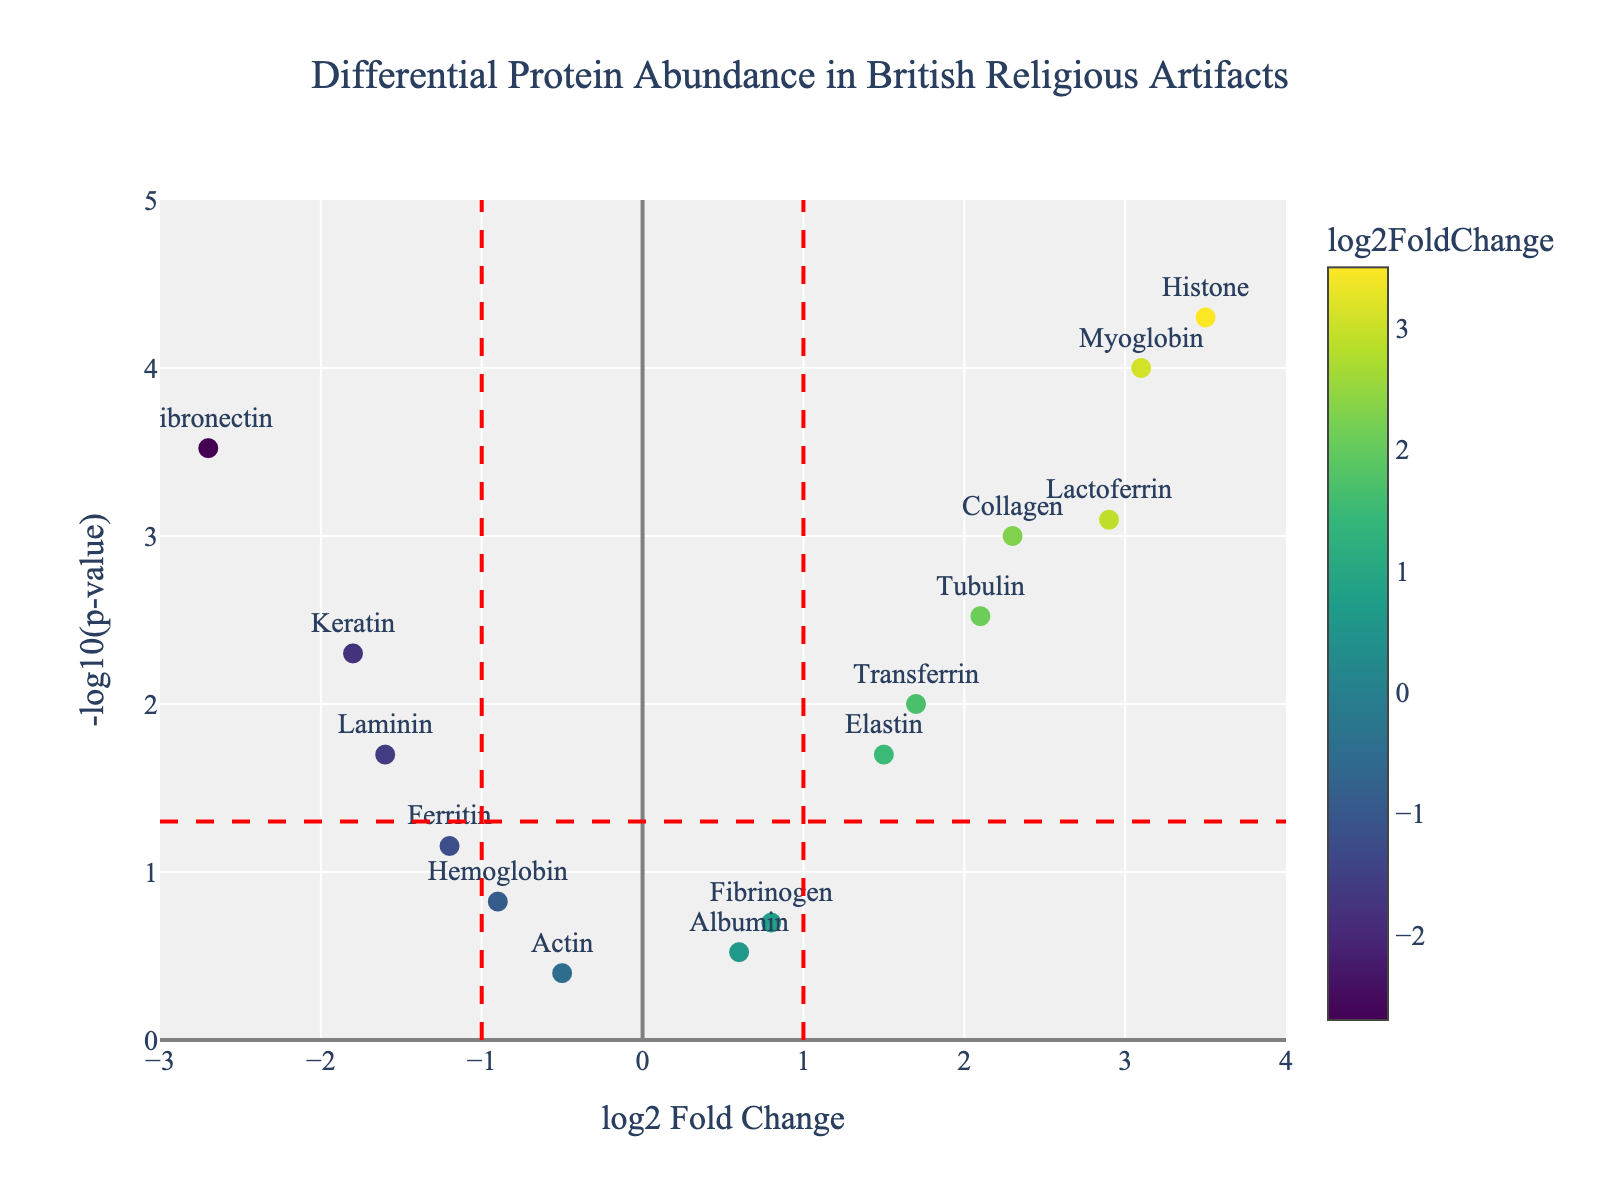How many proteins have a positive log2 Fold Change? To determine this, count the points in the plot that are positioned to the right of the y-axis (log2 Fold Change > 0). From the data, these proteins are Collagen, Myoglobin, Elastin, Lactoferrin, Transferrin, Histone, and Tubulin.
Answer: 7 What is the title of the figure? The title of the figure is displayed at the top center of the plot.
Answer: Differential Protein Abundance in British Religious Artifacts Which protein has the highest -log10(p-value)? By inspecting the y-axis (which represents -log10(p-value)) and finding the highest point on the plot, you can see the protein at the highest position. From the data, Histone has the highest -log10(p-value).
Answer: Histone How many proteins have a p-value less than 0.05? These are the proteins situated above the horizontal red dashed line on the plot, which represents the p-value threshold of 0.05. From the data, the proteins with p-values less than 0.05 are Collagen, Keratin, Myoglobin, Fibronectin, Lactoferrin, Tubulin, Transferrin, and Histone.
Answer: 8 Among the proteins with a negative log2 Fold Change, which one has the lowest p-value? Focus on the points to the left of the y-axis (log2 Fold Change < 0) and find the one highest on the y-axis (-log10(p-value)). From the data, Fibronectin, with a log2 Fold Change of -2.7 and p-value of 0.0003, is the lowest.
Answer: Fibronectin Which protein has the smallest log2 Fold Change among those with a positive log2 Fold Change? Look at the data points to the right of the y-axis and identify the lowest log2 Fold Change value. From the data, the protein is Albumin with a log2 Fold Change of 0.6.
Answer: Albumin What range does the x-axis cover? The range of the x-axis can be seen at the bottom of the plot.
Answer: From -3 to 4 Which proteins are underrepresented (negative log2 Fold Change) and statistically significant (p-value < 0.05)? These proteins are found in the bottom left quadrant (log2 Fold Change < 0 and above the horizontal red line). From the data, Keratin, Fibronectin, and Laminin fit these criteria.
Answer: Keratin, Fibronectin, Laminin How many proteins have a log2 Fold Change greater than 2? By looking at the points positioned to the right of the log2 Fold Change of 2 on the plot, you can determine this. The proteins are Collagen, Myoglobin, Lactoferrin, and Histone.
Answer: 4 What is the log2 Fold Change for the protein 'Myoglobin'? Identify the data point labeled 'Myoglobin' and read the x-axis value. From the data, Myoglobin has a log2 Fold Change of 3.1.
Answer: 3.1 